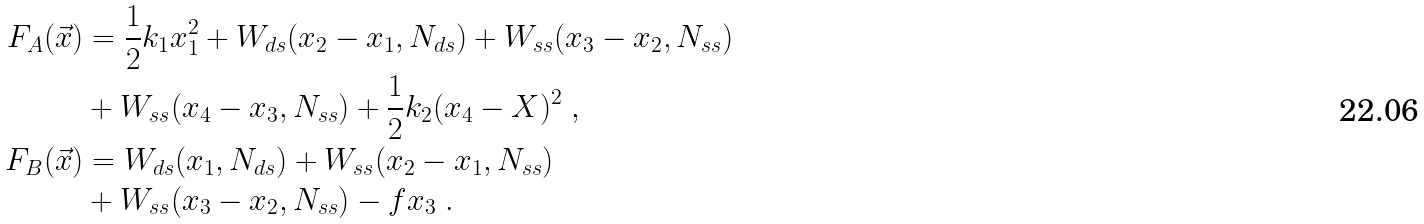<formula> <loc_0><loc_0><loc_500><loc_500>F _ { A } ( \vec { x } ) & = \frac { 1 } { 2 } k _ { 1 } x _ { 1 } ^ { 2 } + W _ { d s } ( x _ { 2 } - x _ { 1 } , N _ { d s } ) + W _ { s s } ( x _ { 3 } - x _ { 2 } , N _ { s s } ) \\ & + W _ { s s } ( x _ { 4 } - x _ { 3 } , N _ { s s } ) + \frac { 1 } { 2 } k _ { 2 } ( x _ { 4 } - X ) ^ { 2 } \ , \\ F _ { B } ( \vec { x } ) & = W _ { d s } ( x _ { 1 } , N _ { d s } ) + W _ { s s } ( x _ { 2 } - x _ { 1 } , N _ { s s } ) \\ & + W _ { s s } ( x _ { 3 } - x _ { 2 } , N _ { s s } ) - f x _ { 3 } \ .</formula> 